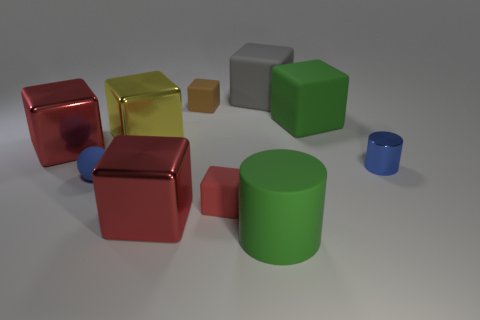Subtract all blue balls. How many red cubes are left? 3 Subtract all red blocks. How many blocks are left? 4 Subtract all big gray blocks. How many blocks are left? 6 Subtract all cyan blocks. Subtract all red spheres. How many blocks are left? 7 Subtract all blocks. How many objects are left? 3 Add 6 tiny yellow cubes. How many tiny yellow cubes exist? 6 Subtract 1 green cylinders. How many objects are left? 9 Subtract all yellow objects. Subtract all yellow blocks. How many objects are left? 8 Add 4 tiny red objects. How many tiny red objects are left? 5 